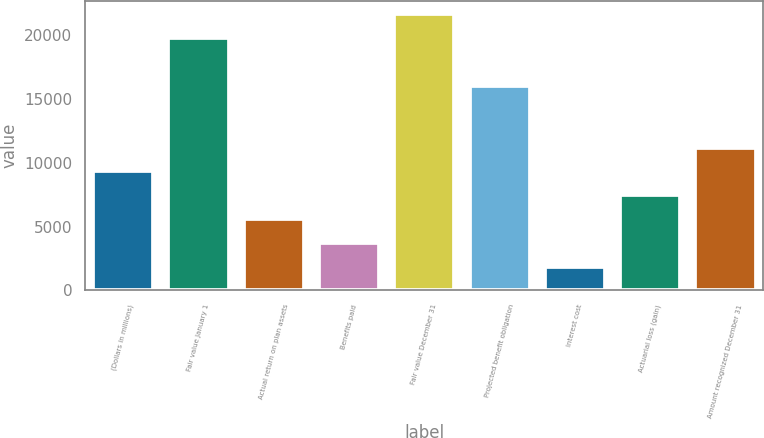Convert chart. <chart><loc_0><loc_0><loc_500><loc_500><bar_chart><fcel>(Dollars in millions)<fcel>Fair value January 1<fcel>Actual return on plan assets<fcel>Benefits paid<fcel>Fair value December 31<fcel>Projected benefit obligation<fcel>Interest cost<fcel>Actuarial loss (gain)<fcel>Amount recognized December 31<nl><fcel>9309.07<fcel>19728<fcel>5587.09<fcel>3726.1<fcel>21589<fcel>16006<fcel>1865.11<fcel>7448.08<fcel>11170.1<nl></chart> 